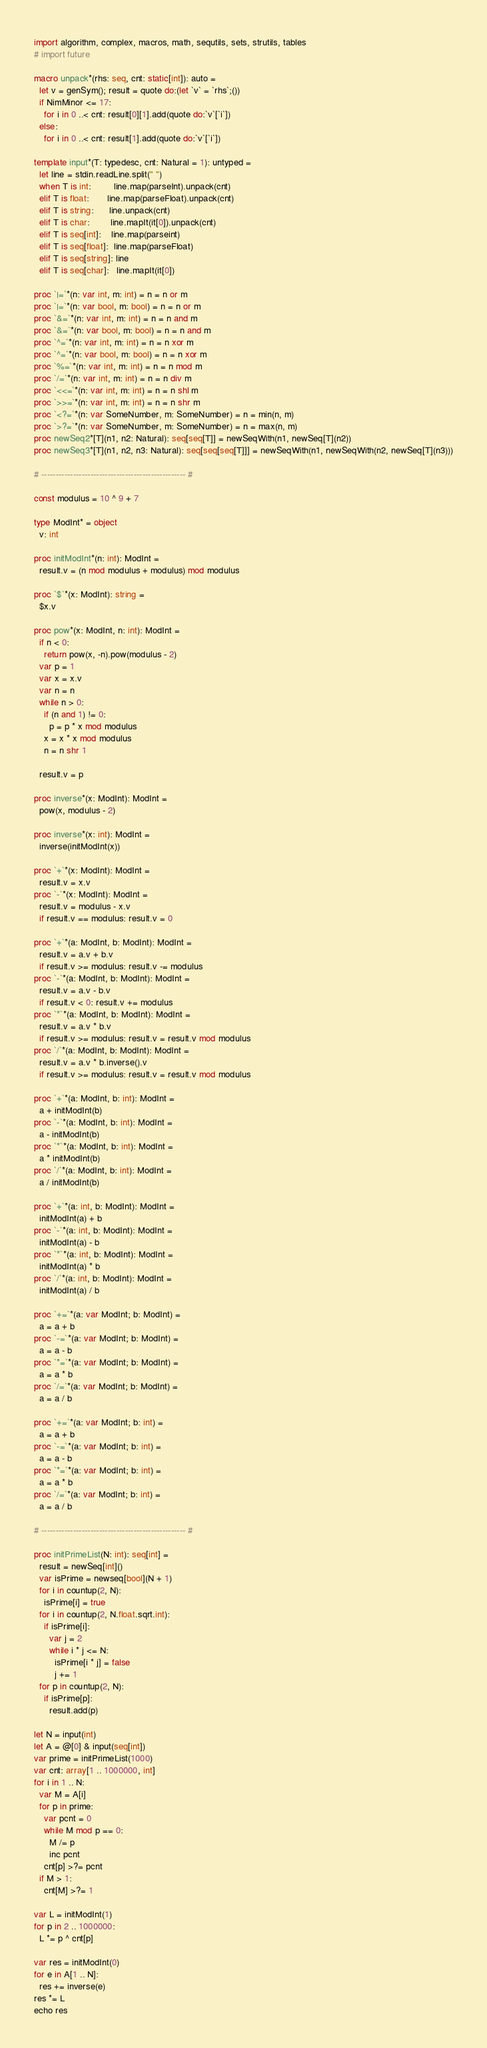<code> <loc_0><loc_0><loc_500><loc_500><_Nim_>import algorithm, complex, macros, math, sequtils, sets, strutils, tables
# import future

macro unpack*(rhs: seq, cnt: static[int]): auto =
  let v = genSym(); result = quote do:(let `v` = `rhs`;())
  if NimMinor <= 17:
    for i in 0 ..< cnt: result[0][1].add(quote do:`v`[`i`])
  else:
    for i in 0 ..< cnt: result[1].add(quote do:`v`[`i`])

template input*(T: typedesc, cnt: Natural = 1): untyped =
  let line = stdin.readLine.split(" ")
  when T is int:         line.map(parseInt).unpack(cnt)
  elif T is float:       line.map(parseFloat).unpack(cnt)
  elif T is string:      line.unpack(cnt)
  elif T is char:        line.mapIt(it[0]).unpack(cnt)
  elif T is seq[int]:    line.map(parseint)
  elif T is seq[float]:  line.map(parseFloat)
  elif T is seq[string]: line
  elif T is seq[char]:   line.mapIt(it[0])

proc `|=`*(n: var int, m: int) = n = n or m
proc `|=`*(n: var bool, m: bool) = n = n or m
proc `&=`*(n: var int, m: int) = n = n and m
proc `&=`*(n: var bool, m: bool) = n = n and m
proc `^=`*(n: var int, m: int) = n = n xor m
proc `^=`*(n: var bool, m: bool) = n = n xor m
proc `%=`*(n: var int, m: int) = n = n mod m
proc `/=`*(n: var int, m: int) = n = n div m
proc `<<=`*(n: var int, m: int) = n = n shl m
proc `>>=`*(n: var int, m: int) = n = n shr m
proc `<?=`*(n: var SomeNumber, m: SomeNumber) = n = min(n, m)
proc `>?=`*(n: var SomeNumber, m: SomeNumber) = n = max(n, m)
proc newSeq2*[T](n1, n2: Natural): seq[seq[T]] = newSeqWith(n1, newSeq[T](n2))
proc newSeq3*[T](n1, n2, n3: Natural): seq[seq[seq[T]]] = newSeqWith(n1, newSeqWith(n2, newSeq[T](n3)))

# -------------------------------------------------- #

const modulus = 10 ^ 9 + 7

type ModInt* = object
  v: int

proc initModInt*(n: int): ModInt =
  result.v = (n mod modulus + modulus) mod modulus

proc `$`*(x: ModInt): string =
  $x.v

proc pow*(x: ModInt, n: int): ModInt =
  if n < 0:
    return pow(x, -n).pow(modulus - 2)
  var p = 1
  var x = x.v
  var n = n
  while n > 0:
    if (n and 1) != 0:
      p = p * x mod modulus
    x = x * x mod modulus
    n = n shr 1

  result.v = p

proc inverse*(x: ModInt): ModInt =
  pow(x, modulus - 2)

proc inverse*(x: int): ModInt =
  inverse(initModInt(x))

proc `+`*(x: ModInt): ModInt =
  result.v = x.v
proc `-`*(x: ModInt): ModInt =
  result.v = modulus - x.v
  if result.v == modulus: result.v = 0

proc `+`*(a: ModInt, b: ModInt): ModInt =
  result.v = a.v + b.v
  if result.v >= modulus: result.v -= modulus
proc `-`*(a: ModInt, b: ModInt): ModInt =
  result.v = a.v - b.v
  if result.v < 0: result.v += modulus
proc `*`*(a: ModInt, b: ModInt): ModInt =
  result.v = a.v * b.v
  if result.v >= modulus: result.v = result.v mod modulus
proc `/`*(a: ModInt, b: ModInt): ModInt =
  result.v = a.v * b.inverse().v
  if result.v >= modulus: result.v = result.v mod modulus

proc `+`*(a: ModInt, b: int): ModInt =
  a + initModInt(b)
proc `-`*(a: ModInt, b: int): ModInt =
  a - initModInt(b)
proc `*`*(a: ModInt, b: int): ModInt =
  a * initModInt(b)
proc `/`*(a: ModInt, b: int): ModInt =
  a / initModInt(b)

proc `+`*(a: int, b: ModInt): ModInt =
  initModInt(a) + b
proc `-`*(a: int, b: ModInt): ModInt =
  initModInt(a) - b
proc `*`*(a: int, b: ModInt): ModInt =
  initModInt(a) * b
proc `/`*(a: int, b: ModInt): ModInt =
  initModInt(a) / b

proc `+=`*(a: var ModInt; b: ModInt) =
  a = a + b
proc `-=`*(a: var ModInt; b: ModInt) =
  a = a - b
proc `*=`*(a: var ModInt; b: ModInt) =
  a = a * b
proc `/=`*(a: var ModInt; b: ModInt) =
  a = a / b

proc `+=`*(a: var ModInt; b: int) =
  a = a + b
proc `-=`*(a: var ModInt; b: int) =
  a = a - b
proc `*=`*(a: var ModInt; b: int) =
  a = a * b
proc `/=`*(a: var ModInt; b: int) =
  a = a / b

# -------------------------------------------------- #

proc initPrimeList(N: int): seq[int] =
  result = newSeq[int]()
  var isPrime = newseq[bool](N + 1)
  for i in countup(2, N):
    isPrime[i] = true
  for i in countup(2, N.float.sqrt.int):
    if isPrime[i]:
      var j = 2
      while i * j <= N:
        isPrime[i * j] = false
        j += 1
  for p in countup(2, N):
    if isPrime[p]:
      result.add(p)

let N = input(int)
let A = @[0] & input(seq[int])
var prime = initPrimeList(1000)
var cnt: array[1 .. 1000000, int]
for i in 1 .. N:
  var M = A[i]
  for p in prime:
    var pcnt = 0
    while M mod p == 0:
      M /= p
      inc pcnt
    cnt[p] >?= pcnt
  if M > 1:
    cnt[M] >?= 1

var L = initModInt(1)
for p in 2 .. 1000000:
  L *= p ^ cnt[p]

var res = initModInt(0)
for e in A[1 .. N]:
  res += inverse(e)
res *= L
echo res</code> 